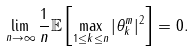Convert formula to latex. <formula><loc_0><loc_0><loc_500><loc_500>\lim _ { n \rightarrow \infty } \frac { 1 } { n } \mathbb { E } \left [ \max _ { 1 \leq k \leq n } | \theta _ { k } ^ { m } | ^ { 2 } \right ] = 0 .</formula> 